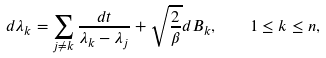<formula> <loc_0><loc_0><loc_500><loc_500>d \lambda _ { k } = \sum _ { j \neq k } \frac { d t } { \lambda _ { k } - \lambda _ { j } } + \sqrt { \frac { 2 } { \beta } } d B _ { k } , \quad 1 \leq k \leq n ,</formula> 